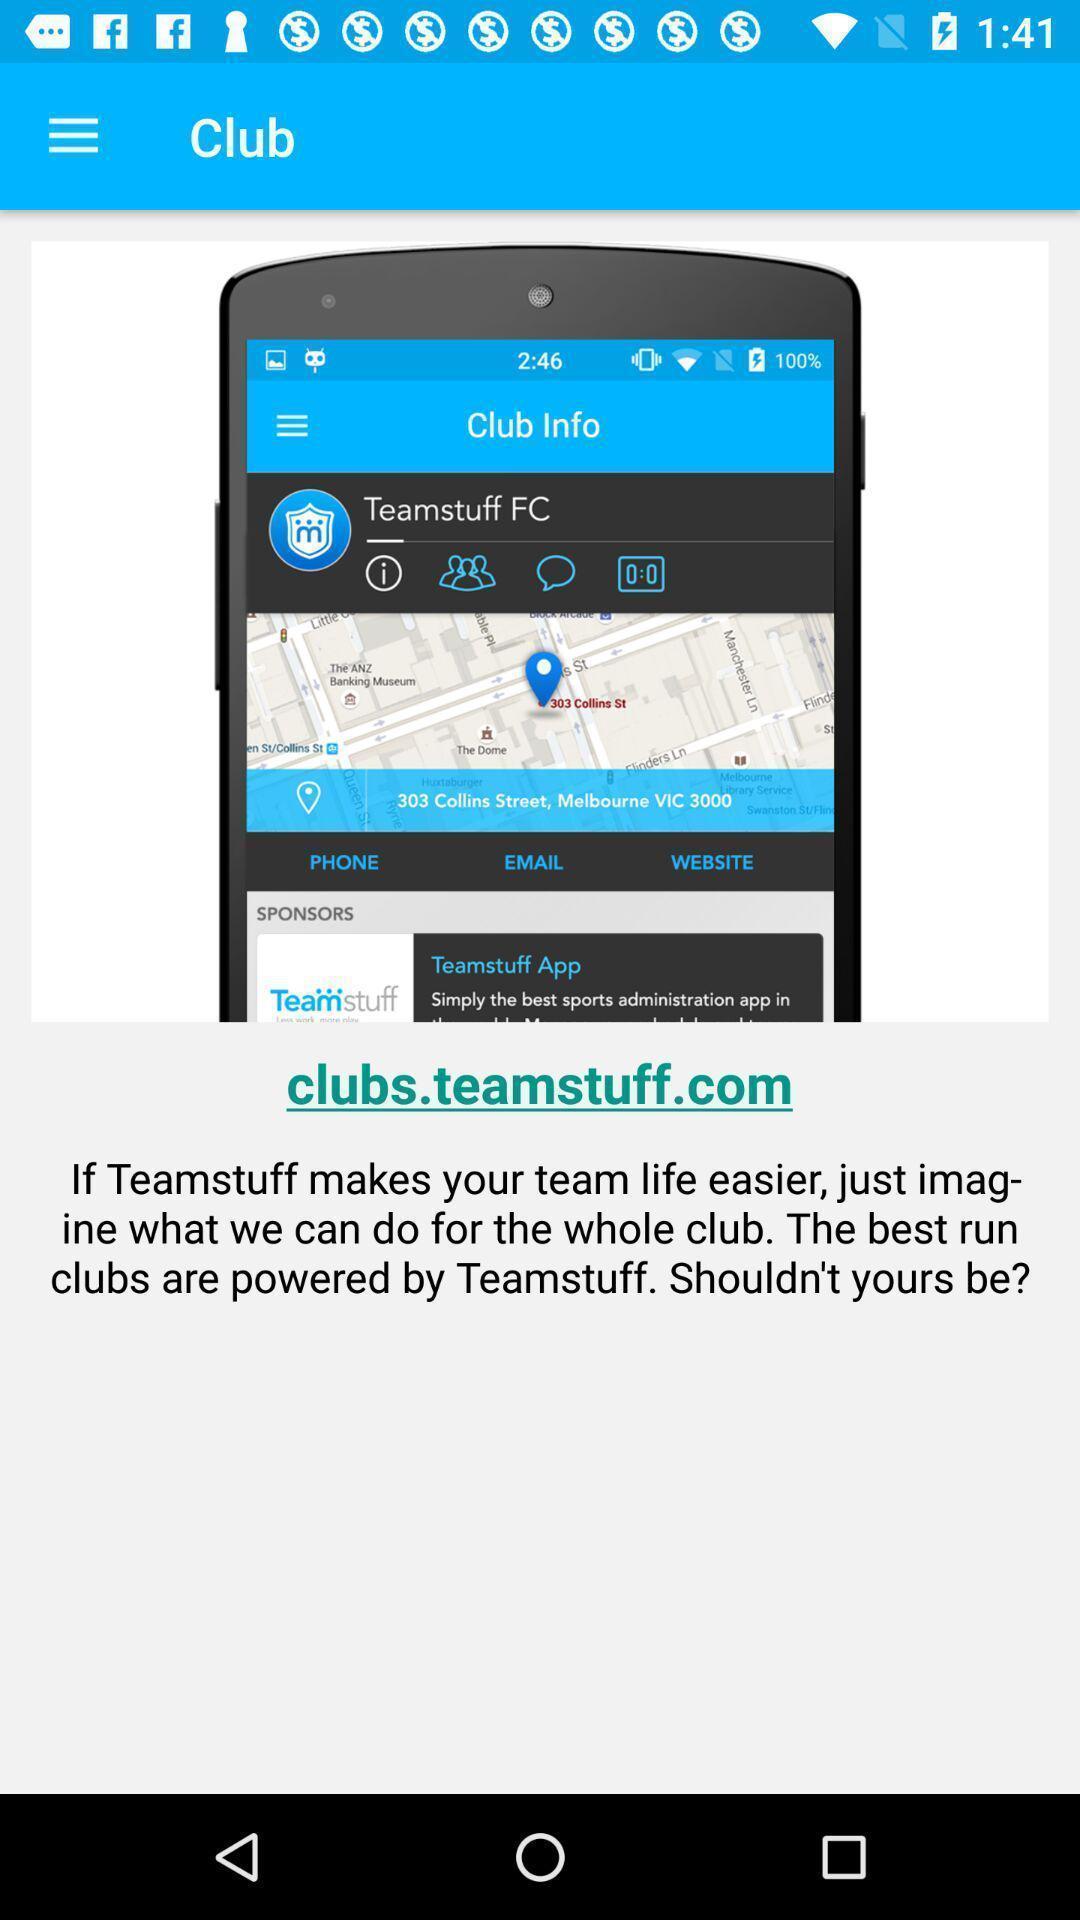Explain the elements present in this screenshot. Welcome page. 